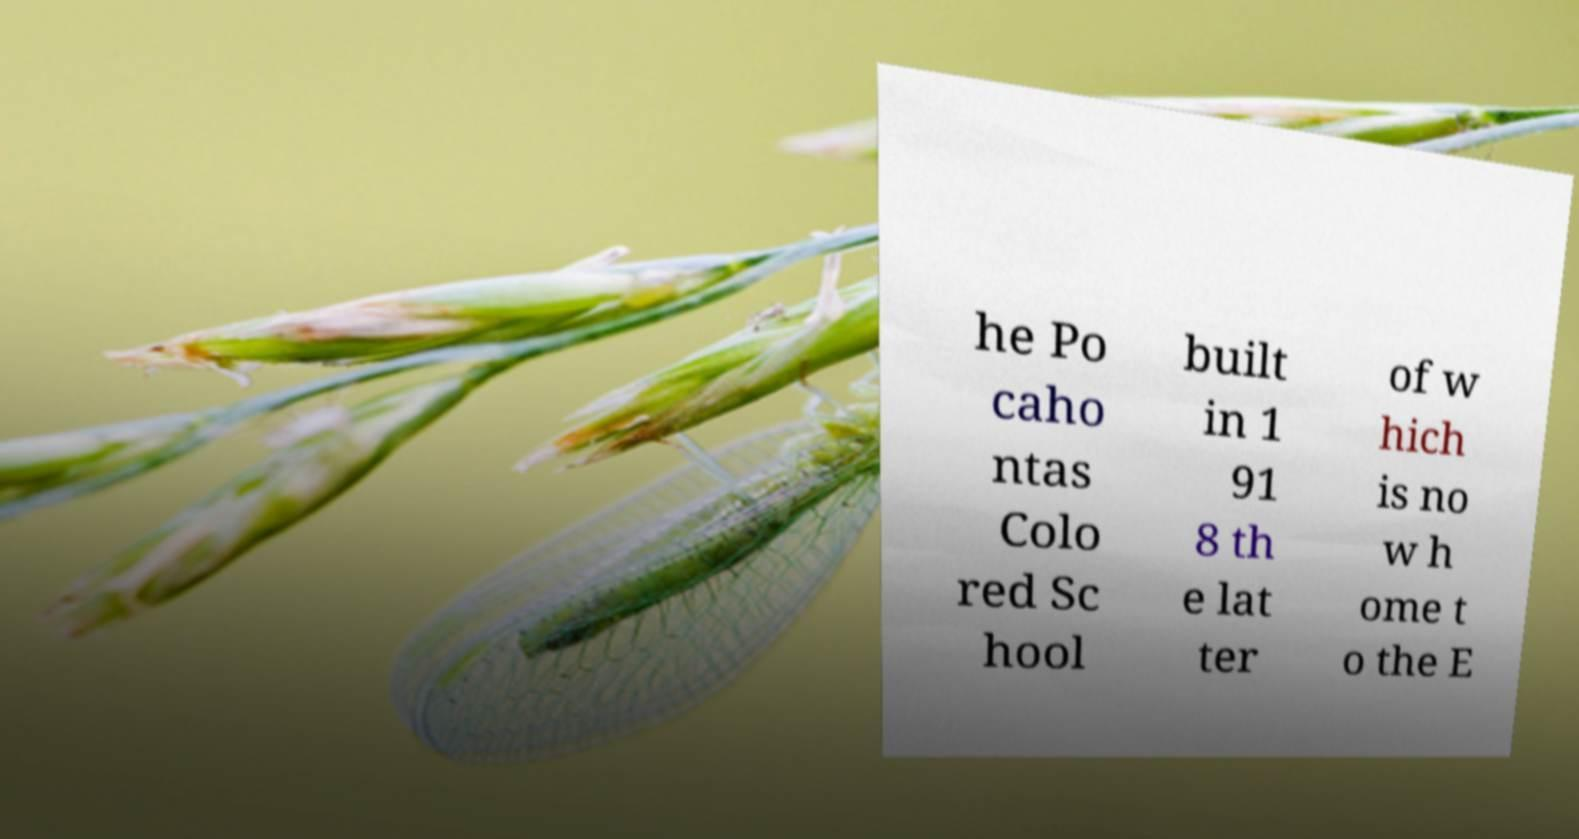For documentation purposes, I need the text within this image transcribed. Could you provide that? he Po caho ntas Colo red Sc hool built in 1 91 8 th e lat ter of w hich is no w h ome t o the E 